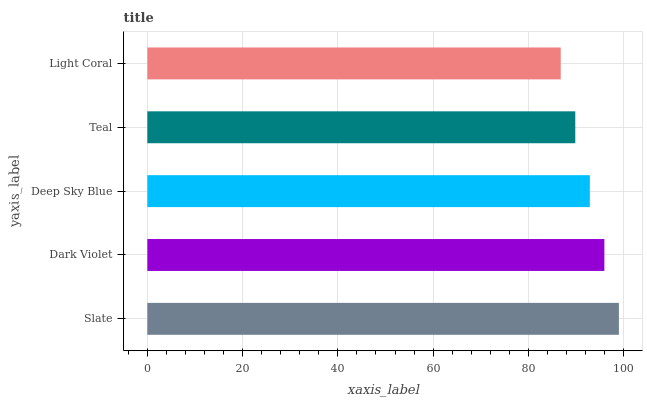Is Light Coral the minimum?
Answer yes or no. Yes. Is Slate the maximum?
Answer yes or no. Yes. Is Dark Violet the minimum?
Answer yes or no. No. Is Dark Violet the maximum?
Answer yes or no. No. Is Slate greater than Dark Violet?
Answer yes or no. Yes. Is Dark Violet less than Slate?
Answer yes or no. Yes. Is Dark Violet greater than Slate?
Answer yes or no. No. Is Slate less than Dark Violet?
Answer yes or no. No. Is Deep Sky Blue the high median?
Answer yes or no. Yes. Is Deep Sky Blue the low median?
Answer yes or no. Yes. Is Teal the high median?
Answer yes or no. No. Is Light Coral the low median?
Answer yes or no. No. 